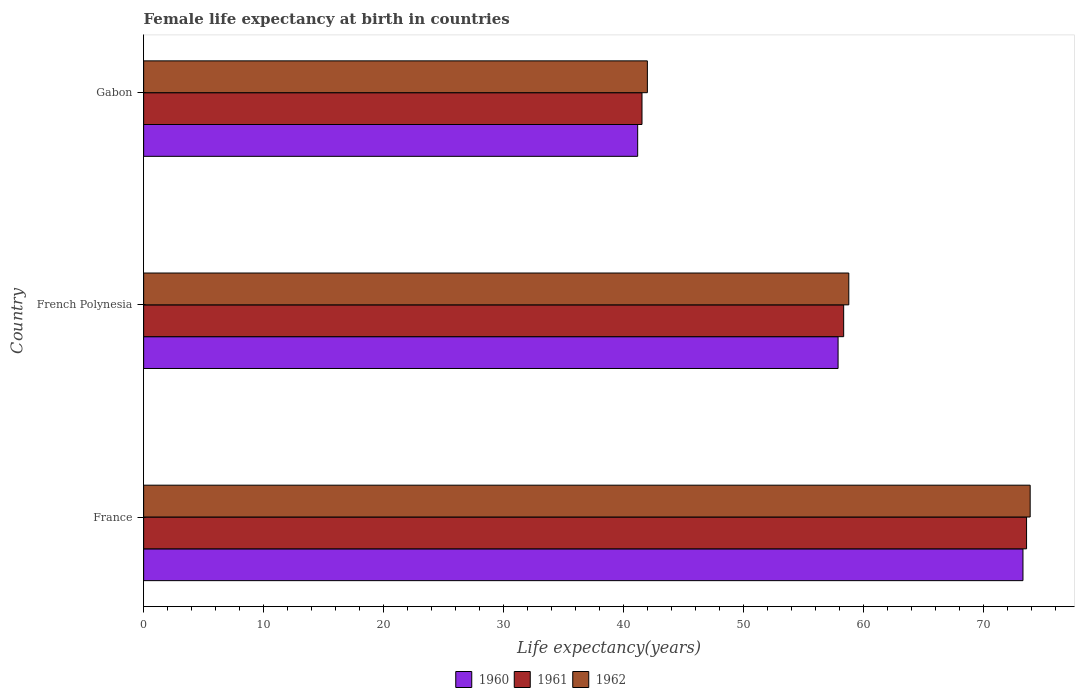How many different coloured bars are there?
Keep it short and to the point. 3. How many groups of bars are there?
Your response must be concise. 3. Are the number of bars on each tick of the Y-axis equal?
Your answer should be very brief. Yes. How many bars are there on the 1st tick from the top?
Keep it short and to the point. 3. What is the label of the 1st group of bars from the top?
Offer a terse response. Gabon. What is the female life expectancy at birth in 1961 in Gabon?
Give a very brief answer. 41.54. Across all countries, what is the maximum female life expectancy at birth in 1962?
Your answer should be very brief. 73.9. Across all countries, what is the minimum female life expectancy at birth in 1962?
Give a very brief answer. 41.99. In which country was the female life expectancy at birth in 1962 minimum?
Your response must be concise. Gabon. What is the total female life expectancy at birth in 1960 in the graph?
Your answer should be compact. 172.37. What is the difference between the female life expectancy at birth in 1961 in French Polynesia and that in Gabon?
Provide a succinct answer. 16.81. What is the difference between the female life expectancy at birth in 1960 in Gabon and the female life expectancy at birth in 1961 in France?
Offer a very short reply. -32.42. What is the average female life expectancy at birth in 1961 per country?
Keep it short and to the point. 57.83. What is the difference between the female life expectancy at birth in 1960 and female life expectancy at birth in 1961 in French Polynesia?
Give a very brief answer. -0.47. In how many countries, is the female life expectancy at birth in 1962 greater than 70 years?
Provide a succinct answer. 1. What is the ratio of the female life expectancy at birth in 1961 in France to that in Gabon?
Your response must be concise. 1.77. Is the female life expectancy at birth in 1960 in French Polynesia less than that in Gabon?
Provide a short and direct response. No. What is the difference between the highest and the second highest female life expectancy at birth in 1962?
Offer a terse response. 15.12. What is the difference between the highest and the lowest female life expectancy at birth in 1960?
Ensure brevity in your answer.  32.12. Is the sum of the female life expectancy at birth in 1960 in France and French Polynesia greater than the maximum female life expectancy at birth in 1962 across all countries?
Keep it short and to the point. Yes. What does the 1st bar from the top in France represents?
Provide a succinct answer. 1962. Are all the bars in the graph horizontal?
Ensure brevity in your answer.  Yes. How many countries are there in the graph?
Keep it short and to the point. 3. Does the graph contain grids?
Offer a terse response. No. How are the legend labels stacked?
Offer a terse response. Horizontal. What is the title of the graph?
Provide a short and direct response. Female life expectancy at birth in countries. What is the label or title of the X-axis?
Offer a very short reply. Life expectancy(years). What is the label or title of the Y-axis?
Keep it short and to the point. Country. What is the Life expectancy(years) of 1960 in France?
Give a very brief answer. 73.3. What is the Life expectancy(years) in 1961 in France?
Your answer should be very brief. 73.6. What is the Life expectancy(years) of 1962 in France?
Make the answer very short. 73.9. What is the Life expectancy(years) of 1960 in French Polynesia?
Keep it short and to the point. 57.89. What is the Life expectancy(years) in 1961 in French Polynesia?
Ensure brevity in your answer.  58.35. What is the Life expectancy(years) of 1962 in French Polynesia?
Give a very brief answer. 58.78. What is the Life expectancy(years) of 1960 in Gabon?
Offer a terse response. 41.18. What is the Life expectancy(years) of 1961 in Gabon?
Ensure brevity in your answer.  41.54. What is the Life expectancy(years) in 1962 in Gabon?
Ensure brevity in your answer.  41.99. Across all countries, what is the maximum Life expectancy(years) in 1960?
Your answer should be very brief. 73.3. Across all countries, what is the maximum Life expectancy(years) in 1961?
Your answer should be compact. 73.6. Across all countries, what is the maximum Life expectancy(years) of 1962?
Give a very brief answer. 73.9. Across all countries, what is the minimum Life expectancy(years) in 1960?
Offer a terse response. 41.18. Across all countries, what is the minimum Life expectancy(years) of 1961?
Provide a succinct answer. 41.54. Across all countries, what is the minimum Life expectancy(years) in 1962?
Offer a very short reply. 41.99. What is the total Life expectancy(years) of 1960 in the graph?
Offer a very short reply. 172.37. What is the total Life expectancy(years) in 1961 in the graph?
Provide a short and direct response. 173.5. What is the total Life expectancy(years) of 1962 in the graph?
Your answer should be compact. 174.67. What is the difference between the Life expectancy(years) in 1960 in France and that in French Polynesia?
Provide a short and direct response. 15.41. What is the difference between the Life expectancy(years) in 1961 in France and that in French Polynesia?
Keep it short and to the point. 15.25. What is the difference between the Life expectancy(years) of 1962 in France and that in French Polynesia?
Provide a succinct answer. 15.12. What is the difference between the Life expectancy(years) in 1960 in France and that in Gabon?
Make the answer very short. 32.12. What is the difference between the Life expectancy(years) of 1961 in France and that in Gabon?
Provide a short and direct response. 32.06. What is the difference between the Life expectancy(years) of 1962 in France and that in Gabon?
Your response must be concise. 31.91. What is the difference between the Life expectancy(years) in 1960 in French Polynesia and that in Gabon?
Offer a terse response. 16.71. What is the difference between the Life expectancy(years) in 1961 in French Polynesia and that in Gabon?
Ensure brevity in your answer.  16.81. What is the difference between the Life expectancy(years) of 1962 in French Polynesia and that in Gabon?
Make the answer very short. 16.79. What is the difference between the Life expectancy(years) of 1960 in France and the Life expectancy(years) of 1961 in French Polynesia?
Give a very brief answer. 14.95. What is the difference between the Life expectancy(years) of 1960 in France and the Life expectancy(years) of 1962 in French Polynesia?
Your answer should be compact. 14.52. What is the difference between the Life expectancy(years) in 1961 in France and the Life expectancy(years) in 1962 in French Polynesia?
Offer a very short reply. 14.82. What is the difference between the Life expectancy(years) of 1960 in France and the Life expectancy(years) of 1961 in Gabon?
Offer a very short reply. 31.76. What is the difference between the Life expectancy(years) in 1960 in France and the Life expectancy(years) in 1962 in Gabon?
Your answer should be very brief. 31.31. What is the difference between the Life expectancy(years) in 1961 in France and the Life expectancy(years) in 1962 in Gabon?
Ensure brevity in your answer.  31.61. What is the difference between the Life expectancy(years) of 1960 in French Polynesia and the Life expectancy(years) of 1961 in Gabon?
Your response must be concise. 16.34. What is the difference between the Life expectancy(years) of 1960 in French Polynesia and the Life expectancy(years) of 1962 in Gabon?
Keep it short and to the point. 15.9. What is the difference between the Life expectancy(years) in 1961 in French Polynesia and the Life expectancy(years) in 1962 in Gabon?
Make the answer very short. 16.36. What is the average Life expectancy(years) in 1960 per country?
Ensure brevity in your answer.  57.46. What is the average Life expectancy(years) in 1961 per country?
Your answer should be compact. 57.83. What is the average Life expectancy(years) in 1962 per country?
Make the answer very short. 58.22. What is the difference between the Life expectancy(years) of 1960 and Life expectancy(years) of 1962 in France?
Your answer should be compact. -0.6. What is the difference between the Life expectancy(years) in 1961 and Life expectancy(years) in 1962 in France?
Your response must be concise. -0.3. What is the difference between the Life expectancy(years) in 1960 and Life expectancy(years) in 1961 in French Polynesia?
Keep it short and to the point. -0.47. What is the difference between the Life expectancy(years) of 1960 and Life expectancy(years) of 1962 in French Polynesia?
Your response must be concise. -0.89. What is the difference between the Life expectancy(years) in 1961 and Life expectancy(years) in 1962 in French Polynesia?
Your answer should be very brief. -0.43. What is the difference between the Life expectancy(years) of 1960 and Life expectancy(years) of 1961 in Gabon?
Offer a terse response. -0.36. What is the difference between the Life expectancy(years) of 1960 and Life expectancy(years) of 1962 in Gabon?
Offer a terse response. -0.81. What is the difference between the Life expectancy(years) of 1961 and Life expectancy(years) of 1962 in Gabon?
Offer a terse response. -0.45. What is the ratio of the Life expectancy(years) of 1960 in France to that in French Polynesia?
Give a very brief answer. 1.27. What is the ratio of the Life expectancy(years) of 1961 in France to that in French Polynesia?
Provide a succinct answer. 1.26. What is the ratio of the Life expectancy(years) in 1962 in France to that in French Polynesia?
Provide a short and direct response. 1.26. What is the ratio of the Life expectancy(years) of 1960 in France to that in Gabon?
Ensure brevity in your answer.  1.78. What is the ratio of the Life expectancy(years) in 1961 in France to that in Gabon?
Provide a short and direct response. 1.77. What is the ratio of the Life expectancy(years) in 1962 in France to that in Gabon?
Provide a short and direct response. 1.76. What is the ratio of the Life expectancy(years) of 1960 in French Polynesia to that in Gabon?
Make the answer very short. 1.41. What is the ratio of the Life expectancy(years) in 1961 in French Polynesia to that in Gabon?
Your answer should be compact. 1.4. What is the ratio of the Life expectancy(years) of 1962 in French Polynesia to that in Gabon?
Your answer should be very brief. 1.4. What is the difference between the highest and the second highest Life expectancy(years) in 1960?
Provide a short and direct response. 15.41. What is the difference between the highest and the second highest Life expectancy(years) in 1961?
Ensure brevity in your answer.  15.25. What is the difference between the highest and the second highest Life expectancy(years) of 1962?
Your answer should be very brief. 15.12. What is the difference between the highest and the lowest Life expectancy(years) in 1960?
Ensure brevity in your answer.  32.12. What is the difference between the highest and the lowest Life expectancy(years) in 1961?
Give a very brief answer. 32.06. What is the difference between the highest and the lowest Life expectancy(years) in 1962?
Give a very brief answer. 31.91. 